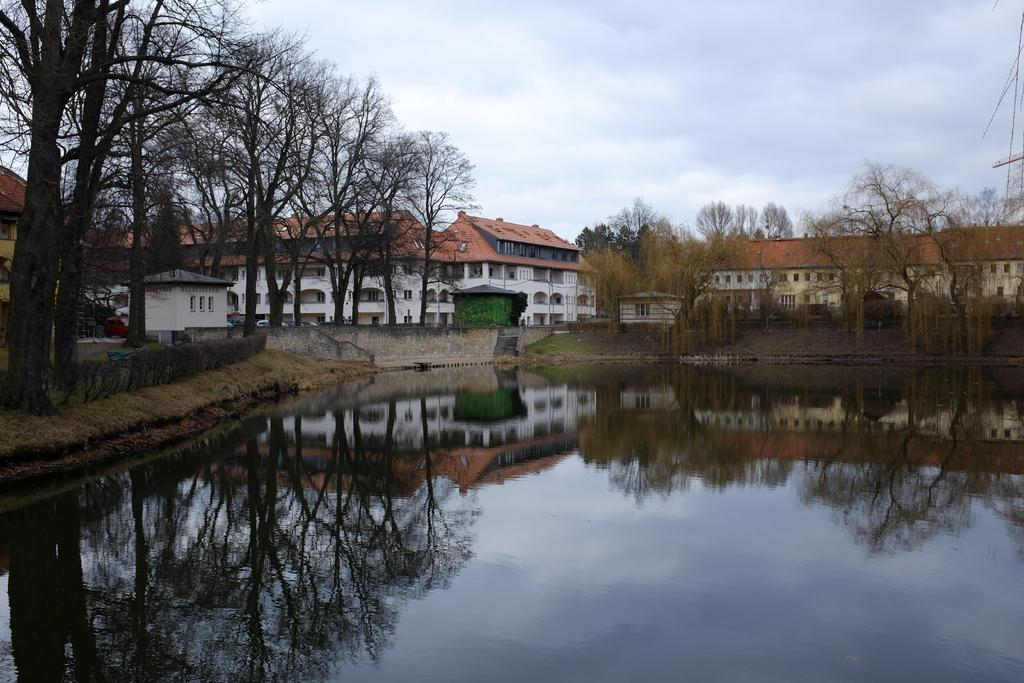What is the primary element visible in the image? There is water in the image. What can be seen behind the water? There are buildings and trees behind the water. What is the effect of the water on the surrounding environment? The reflection of buildings and trees can be seen in the water. How would you describe the weather based on the image? The sky is cloudy in the image. How much wealth is represented by the water in the image? The image does not provide any information about the wealth represented by the water. Can you see the tongue of the person taking the picture in the image? There is no person taking the picture in the image, and therefore no tongue is visible. 